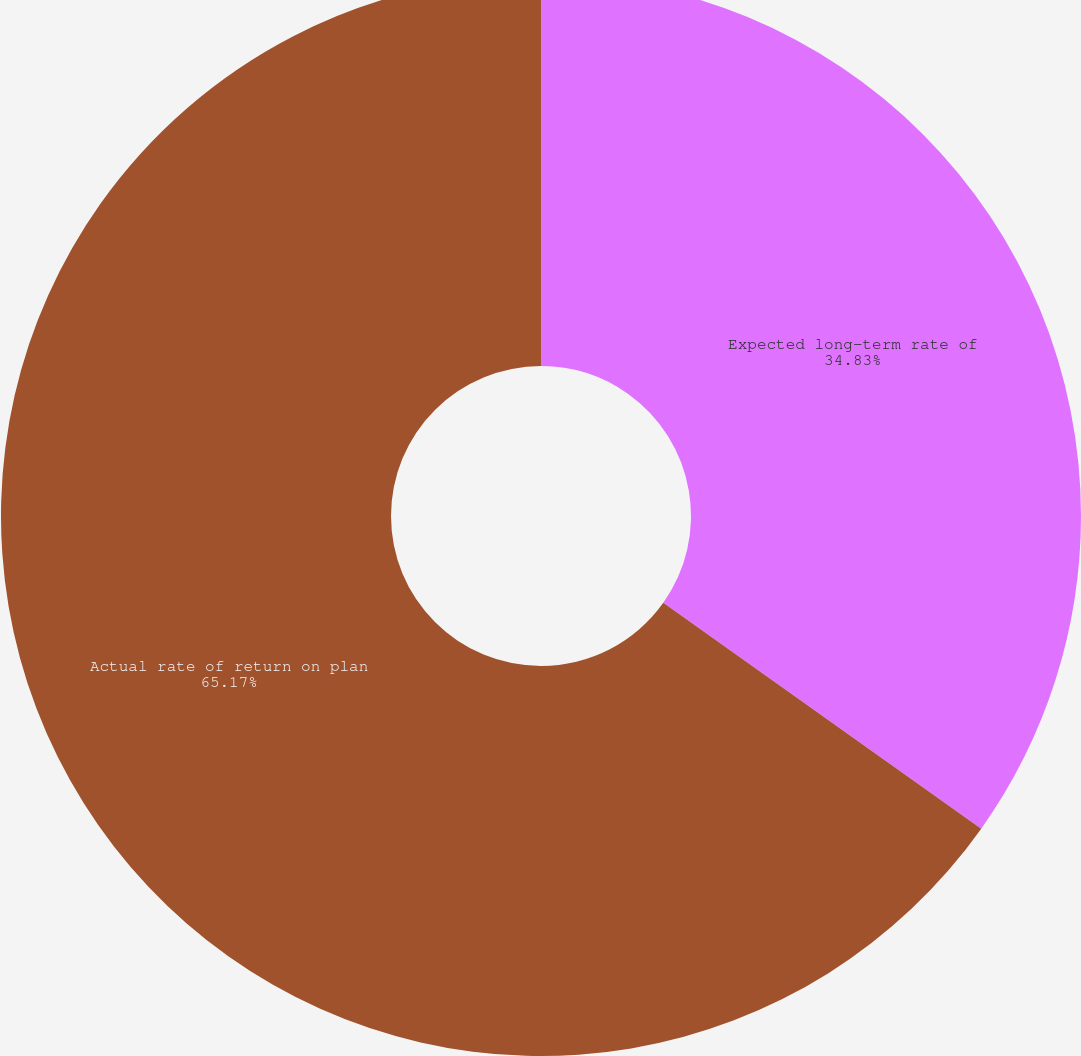Convert chart to OTSL. <chart><loc_0><loc_0><loc_500><loc_500><pie_chart><fcel>Expected long-term rate of<fcel>Actual rate of return on plan<nl><fcel>34.83%<fcel>65.17%<nl></chart> 